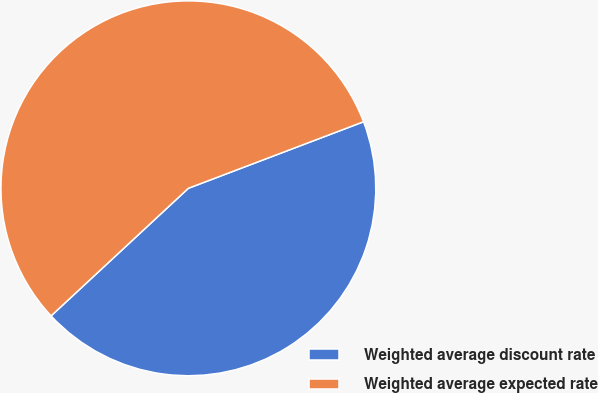Convert chart. <chart><loc_0><loc_0><loc_500><loc_500><pie_chart><fcel>Weighted average discount rate<fcel>Weighted average expected rate<nl><fcel>43.86%<fcel>56.14%<nl></chart> 